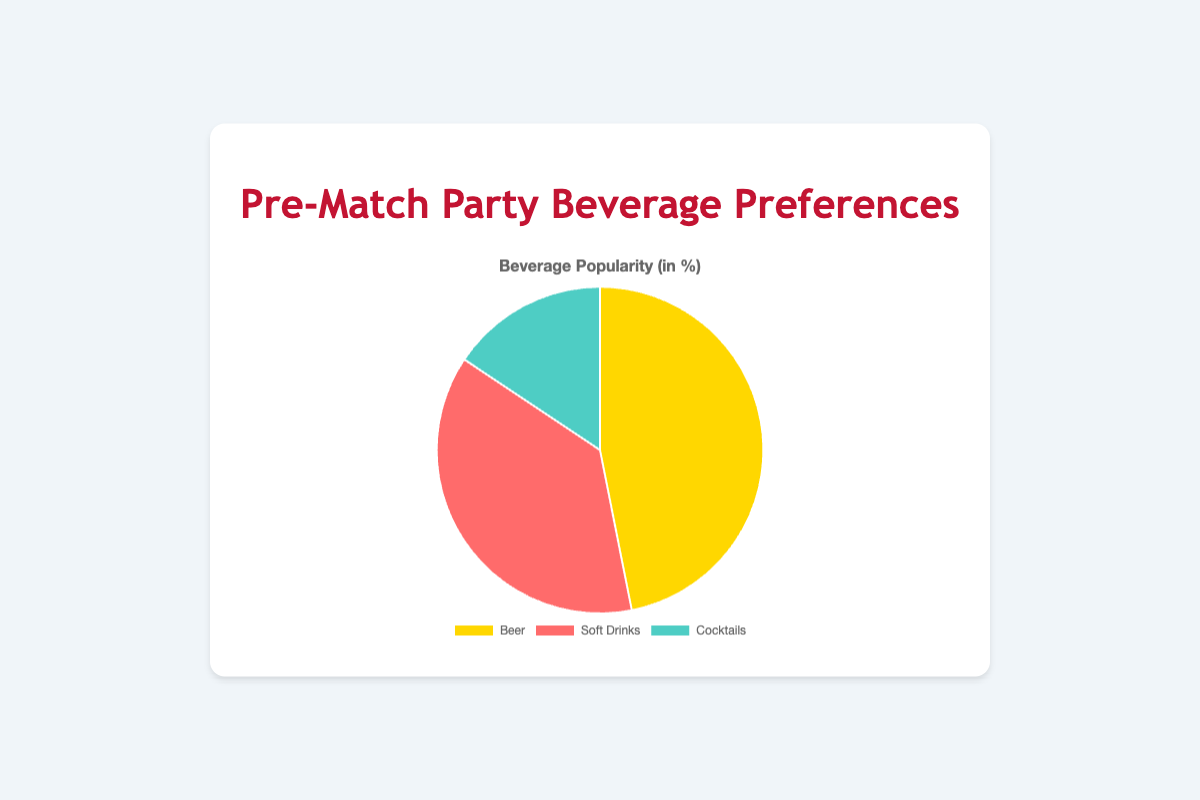Which beverage category is the most preferred at pre-match parties? The largest section of the pie chart, which is highlighted in yellow, represents beer. This indicates that beer is the most preferred beverage category at pre-match parties.
Answer: Beer How much more popular is beer than cocktails in percentage? The pie chart shows that beer has 75% popularity and cocktails have 25%. To find how much more popular beer is than cocktails, subtract the percentage of cocktails from the percentage of beer (75% - 25% = 50%).
Answer: 50% What is the combined percentage for soft drinks and cocktails? The pie chart shows the percentages for soft drinks and cocktails as 60% and 25%, respectively. Adding these two percentages together gives (60% + 25% = 85%).
Answer: 85% Which beverage category is represented by the color red? The pie chart segment colored in red represents soft drinks, as indicated by the chart's legend and color-coding.
Answer: Soft Drinks What percentage of beverage preferences do cocktails and beer together account for? The pie chart segments for cocktails and beer are labeled with percentages of 25% and 75%, respectively. Adding these two gives (25% + 75% = 100%).
Answer: 100% What is the percentage difference between soft drinks and beer preferences? The pie chart shows that soft drinks make up 60% and beer makes up 75%. Subtracting the percentage of soft drinks from the percentage of beer (75% - 60% = 15%) gives the difference.
Answer: 15% If beer represents 75%, what fraction of the pie chart does it represent? Since beer makes up 75% of the pie chart, it represents 75/100 of the chart. Simplifying this fraction, we get 3/4.
Answer: 3/4 What percentage of the chart is not taken up by cocktails? The pie chart shows that cocktails make up 25% of the chart. To find the percentage not taken up by cocktails, subtract this from 100% (100% - 25% = 75%).
Answer: 75% Which segment is the smallest in the pie chart? The pie chart segments indicate the percentages for cocktails, beer, and soft drinks. Cocktails, at 25%, represent the smallest segment in the chart.
Answer: Cocktails 